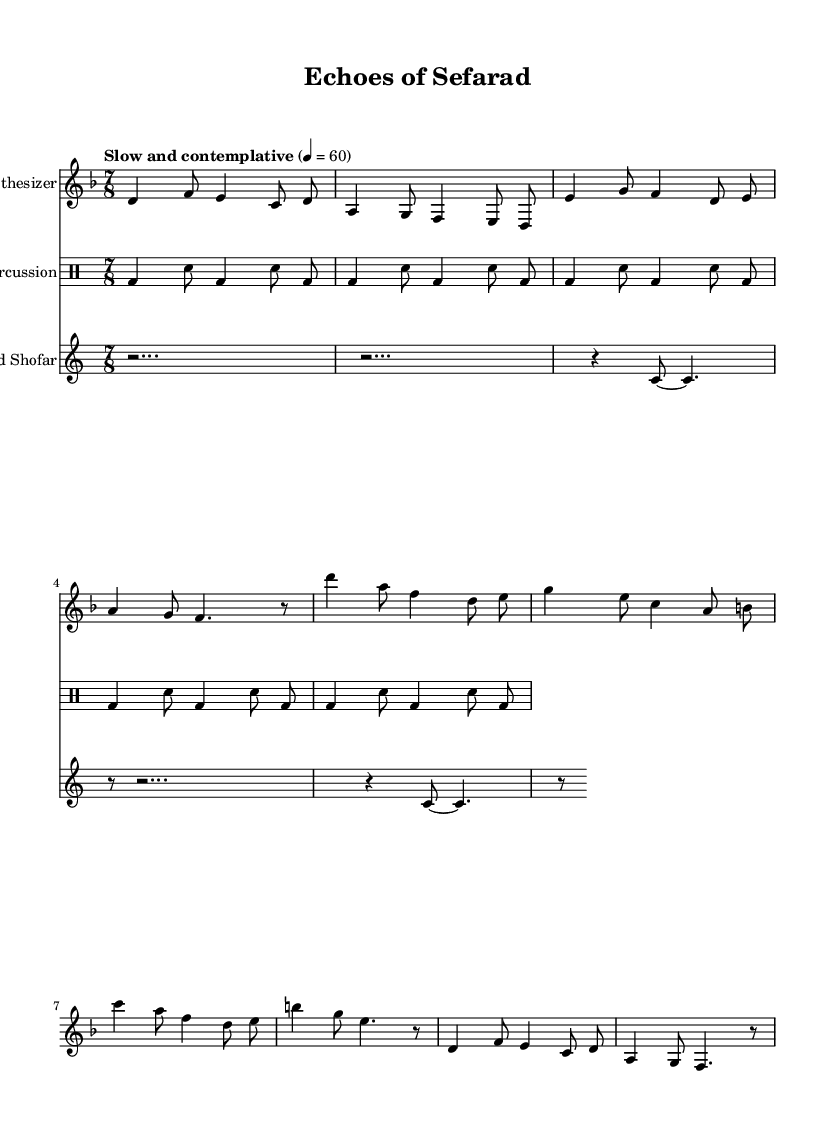What is the key signature of this music? The key signature is D minor, which contains one flat (B flat). This can be identified from the key signature indicated at the beginning of the score.
Answer: D minor What is the time signature of this composition? The time signature is 7/8, which is explicitly stated at the beginning of the score. It indicates that there are seven beats in a measure and each beat is an eighth note.
Answer: 7/8 What is the tempo marking for the piece? The tempo marking is "Slow and contemplative," which indicates the mood and speed at which the piece should be played. This is found at the beginning under the tempo indication.
Answer: Slow and contemplative How many measures are in the synthesizer part? To determine the number of measures, we count the distinct groups of notes separated by bar lines in the synthesizer part. There are eight measures total.
Answer: 8 Which instrument plays the processed shofar line? The processed shofar part is labeled as "Processed Shofar" in the score, indicating which instrument is responsible for that line. The name is above the notation for the shofar.
Answer: Processed Shofar What rhythmic pattern does the percussion part primarily use? The percussion part utilizes a combination of bass drum (bd) and snare drum (sn) hits. The rhythm consists of alternating patterns of quarter and eighth notes, creating a steady pulse throughout.
Answer: Alternating bass and snare In which section does the synthesizer part vary? The synthesizer part varies during the second verse, which is indicated explicitly in the notation with the label "Verse (variation)." This part differs from the initial verse, showcasing musical development.
Answer: Verse (variation) 